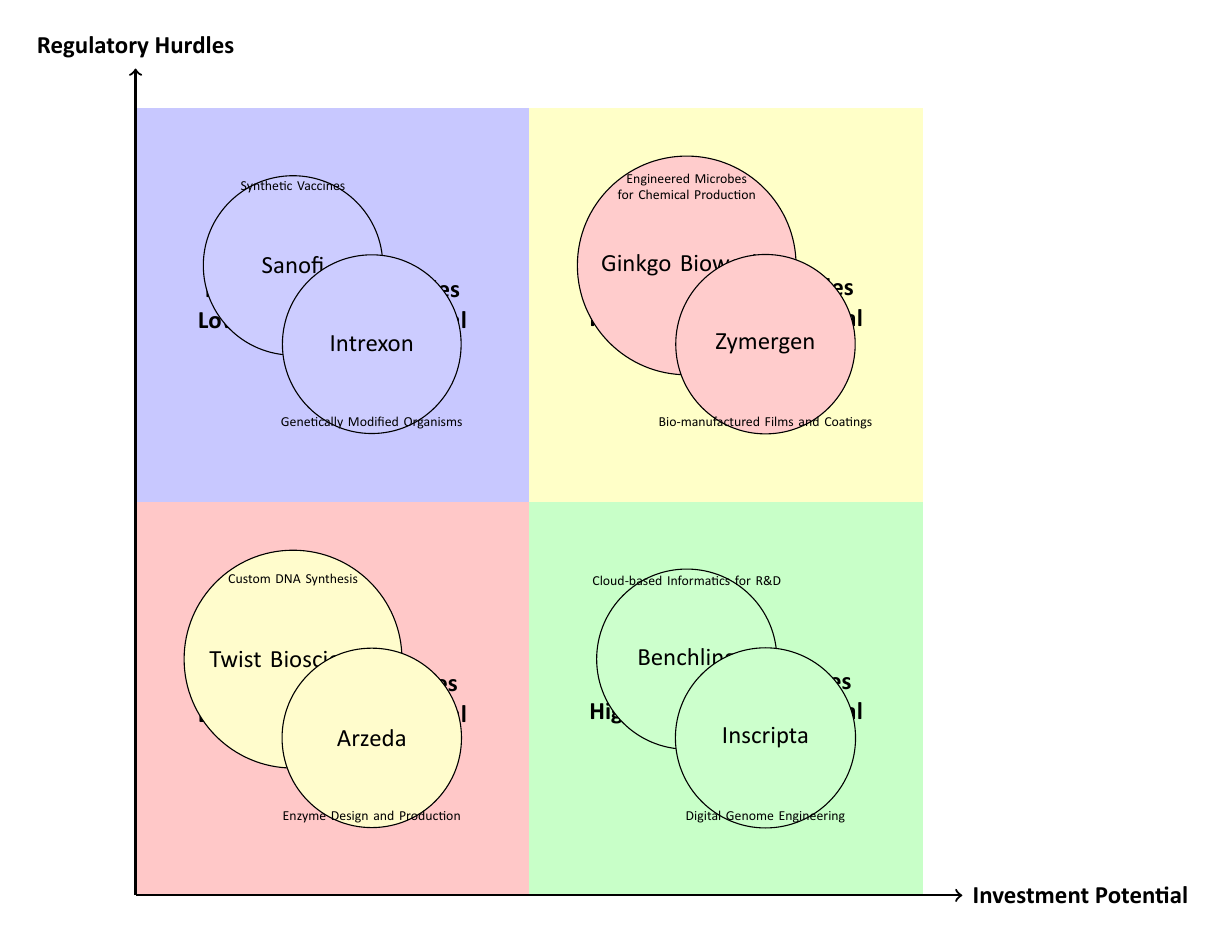What companies are in the high investment potential, high regulatory hurdles quadrant? The high investment potential, high regulatory hurdles quadrant includes companies that are positioned in the top right section of the diagram. These companies are Ginkgo Bioworks and Zymergen.
Answer: Ginkgo Bioworks, Zymergen Which company is associated with digital genome engineering? This question requires identifying the company in the low regulatory hurdles, high investment potential quadrant that mentions digital genome engineering. The company Inscripta is labeled with this innovation.
Answer: Inscripta How many companies are shown in the low investment potential, low regulatory hurdles quadrant? By counting the nodes in the lower left section of the diagram, we can see there are two companies: Twist Bioscience and Arzeda.
Answer: 2 What is the regulatory challenge for Ginkgo Bioworks? To answer this, we look for the regulatory challenge listed next to Ginkgo Bioworks in the diagram, which is the FDA Approval Process.
Answer: FDA Approval Process Which quadrant contains the company Sanofi? To determine the quadrant, we can reference the location of Sanofi in the diagram. Sanofi is positioned in the top left quadrant, which is designated for high regulatory hurdles and low investment potential.
Answer: High Regulatory Hurdles, Low Investment Potential What is the investment highlight for Zymergen? This question focuses on identifying the investment highlight associated with Zymergen in the diagram, which indicates its financial performance, specifically pointing to its IPO on NASDAQ.
Answer: IPO on NASDAQ Which quadrant is characterized by low regulatory hurdles and high investment potential? This question requires us to identify the quadrant that reflects a combination of low regulatory hurdles along with high investment potential, which is the bottom right quadrant.
Answer: Low Regulatory Hurdles, High Investment Potential What is the total number of companies represented in the diagram? By counting all the companies distributed across the four quadrants, we find a total of eight companies represented, as they are divided into high/low investment potential and high/low regulatory hurdles.
Answer: 8 